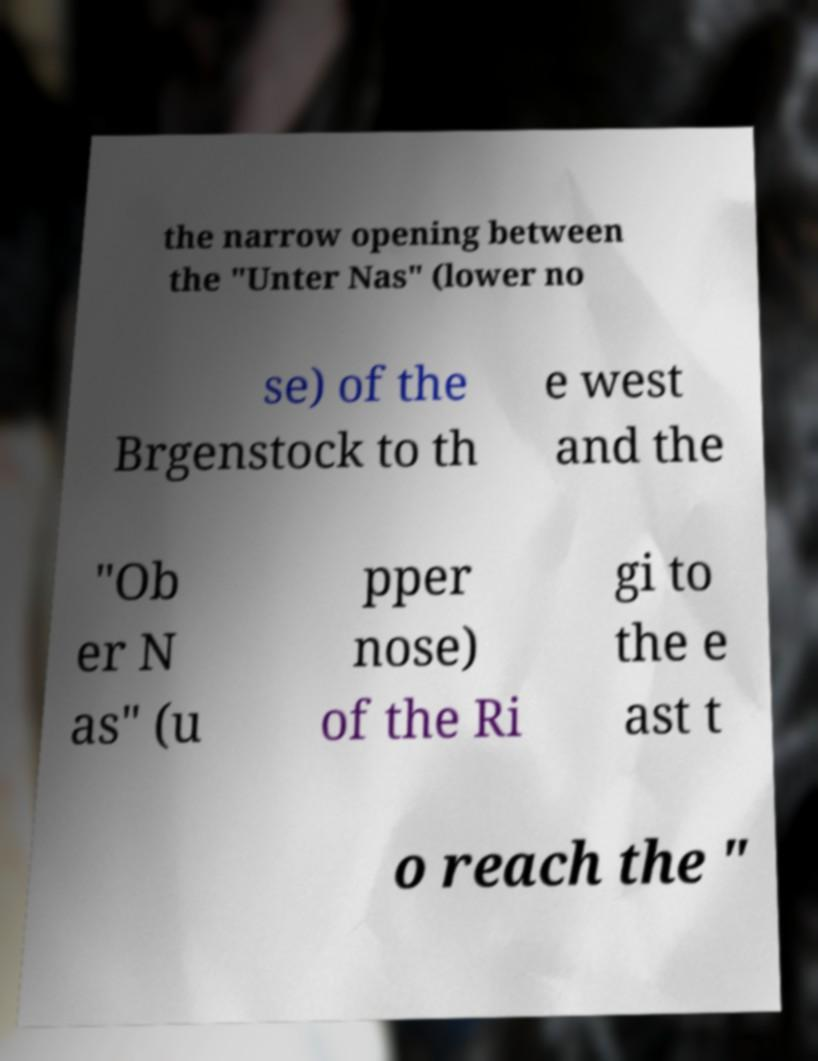There's text embedded in this image that I need extracted. Can you transcribe it verbatim? the narrow opening between the "Unter Nas" (lower no se) of the Brgenstock to th e west and the "Ob er N as" (u pper nose) of the Ri gi to the e ast t o reach the " 